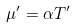Convert formula to latex. <formula><loc_0><loc_0><loc_500><loc_500>\mu ^ { \prime } = \alpha T ^ { \prime }</formula> 